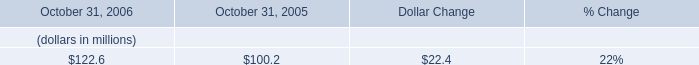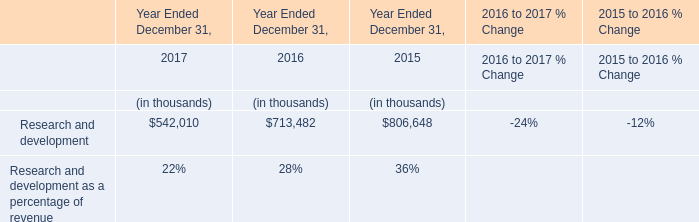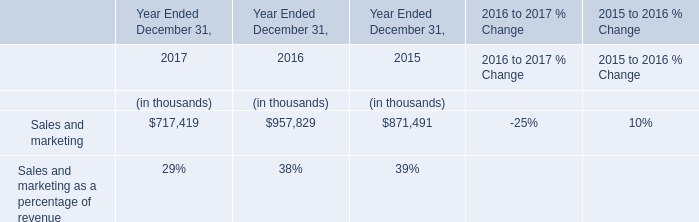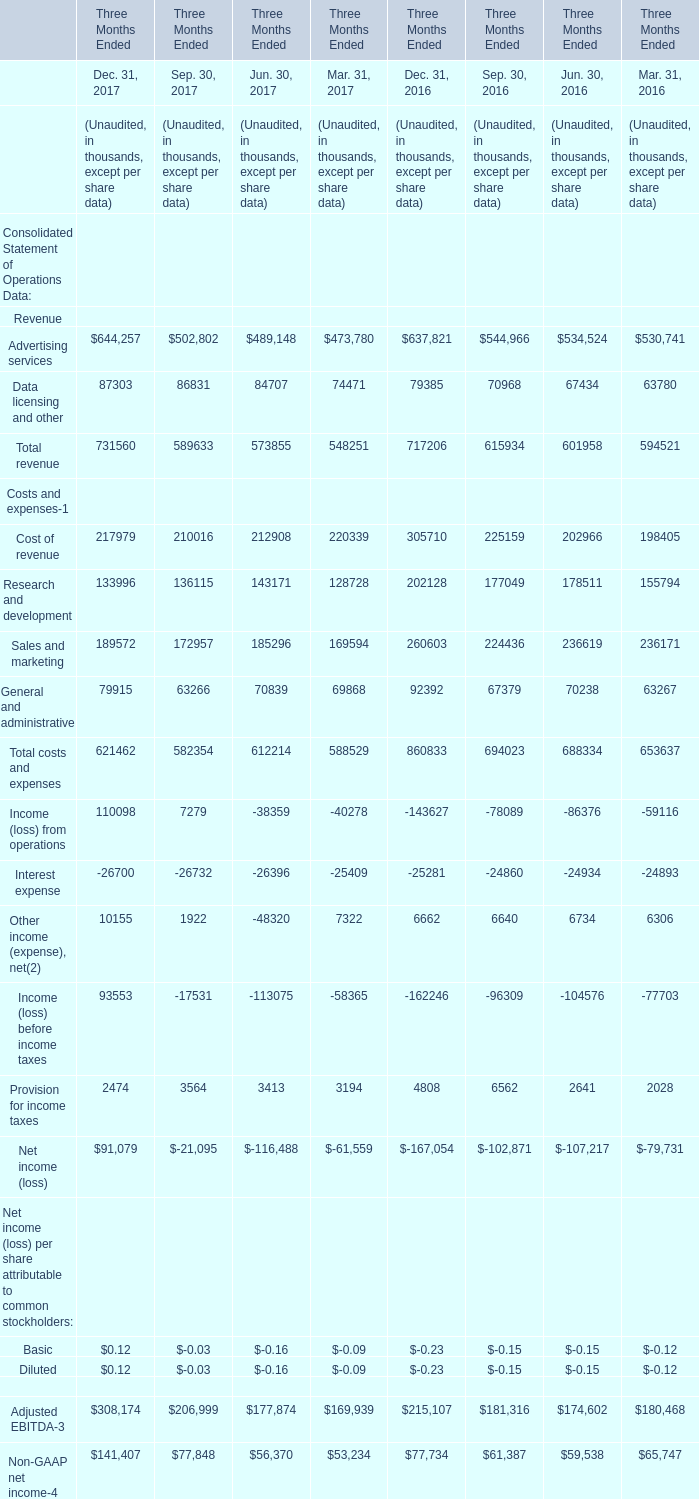what was the change in dso between 2005 and 2006? 
Computations: (39 - 36)
Answer: 3.0. 